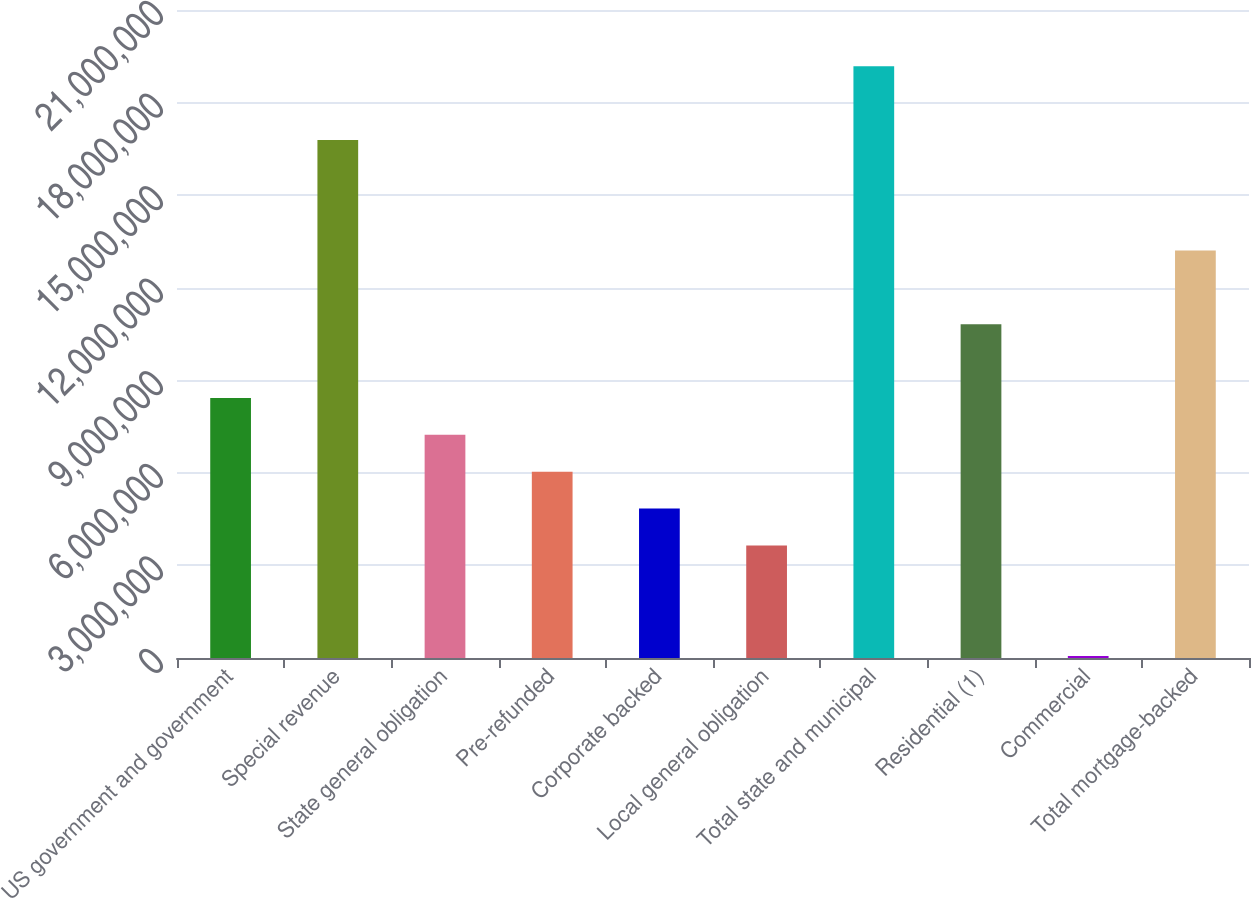Convert chart. <chart><loc_0><loc_0><loc_500><loc_500><bar_chart><fcel>US government and government<fcel>Special revenue<fcel>State general obligation<fcel>Pre-refunded<fcel>Corporate backed<fcel>Local general obligation<fcel>Total state and municipal<fcel>Residential (1)<fcel>Commercial<fcel>Total mortgage-backed<nl><fcel>8.42792e+06<fcel>1.67909e+07<fcel>7.23321e+06<fcel>6.03851e+06<fcel>4.8438e+06<fcel>3.64909e+06<fcel>1.91803e+07<fcel>1.08173e+07<fcel>64975<fcel>1.32067e+07<nl></chart> 